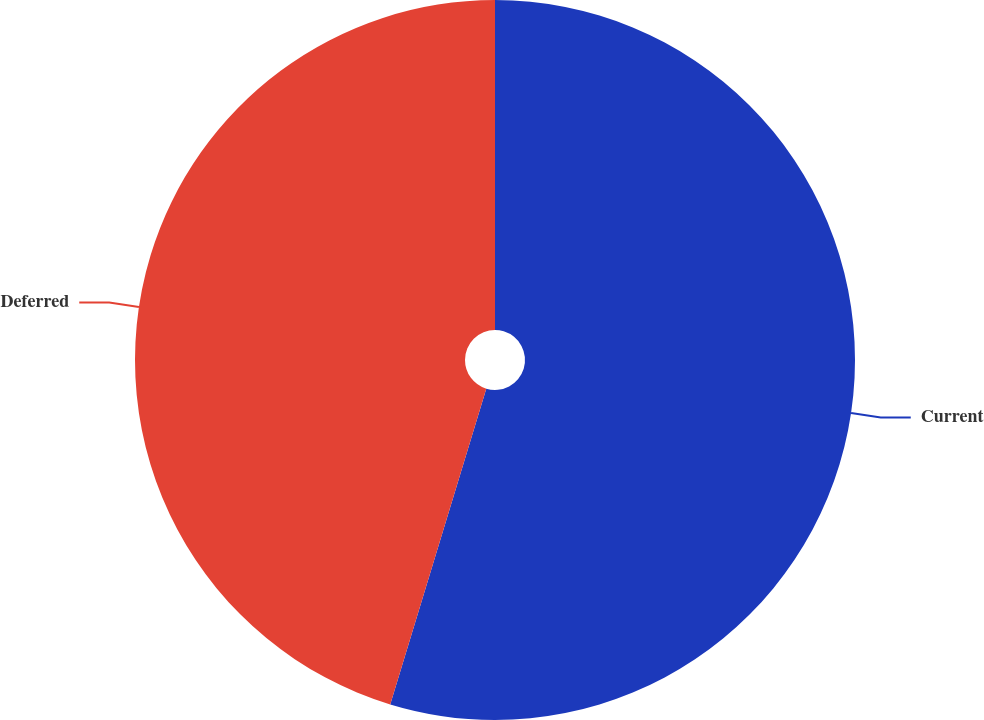Convert chart. <chart><loc_0><loc_0><loc_500><loc_500><pie_chart><fcel>Current<fcel>Deferred<nl><fcel>54.7%<fcel>45.3%<nl></chart> 